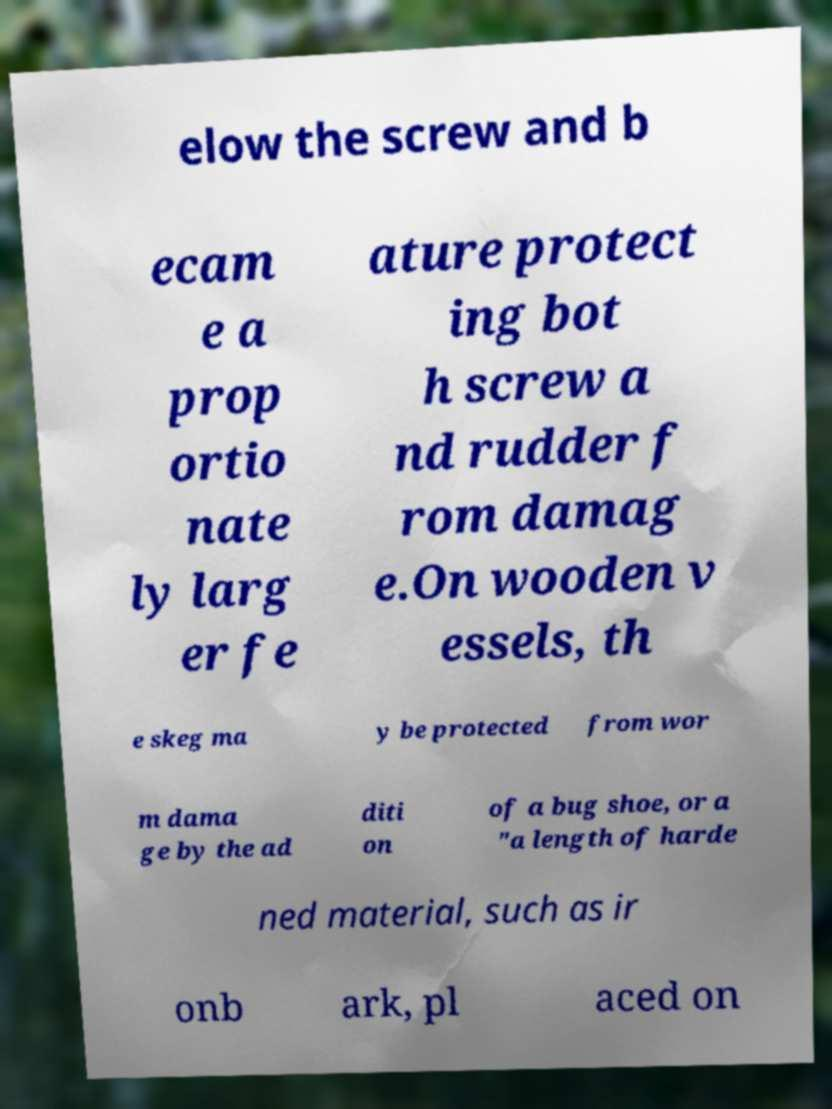Please read and relay the text visible in this image. What does it say? elow the screw and b ecam e a prop ortio nate ly larg er fe ature protect ing bot h screw a nd rudder f rom damag e.On wooden v essels, th e skeg ma y be protected from wor m dama ge by the ad diti on of a bug shoe, or a "a length of harde ned material, such as ir onb ark, pl aced on 